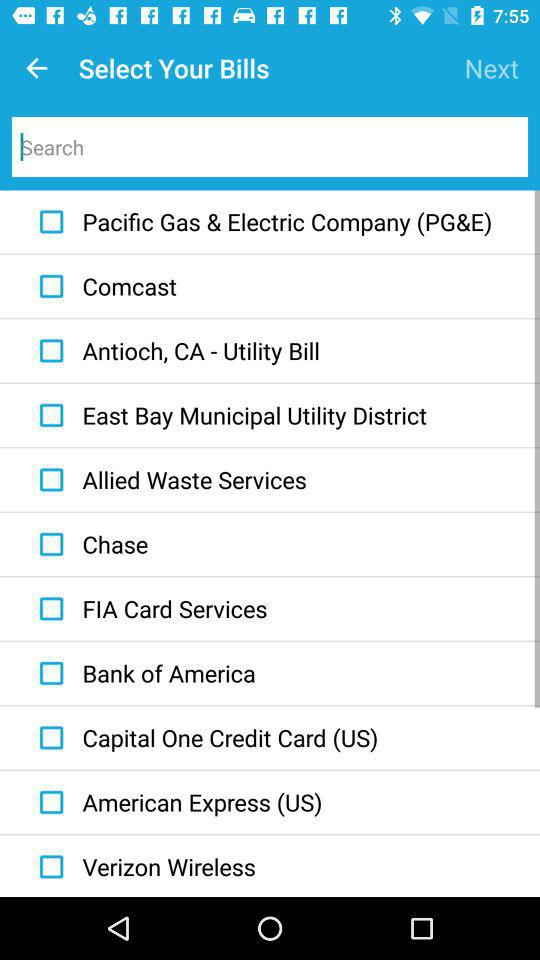Is Comcast selected or not?
When the provided information is insufficient, respond with <no answer>. <no answer> 